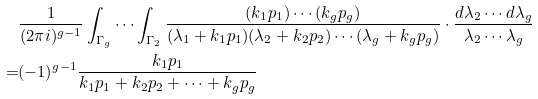<formula> <loc_0><loc_0><loc_500><loc_500>& \frac { 1 } { ( 2 \pi i ) ^ { g - 1 } } \int _ { \Gamma _ { g } } \cdots \int _ { \Gamma _ { 2 } } \frac { ( k _ { 1 } p _ { 1 } ) \cdots ( k _ { g } p _ { g } ) } { ( \lambda _ { 1 } + k _ { 1 } p _ { 1 } ) ( \lambda _ { 2 } + k _ { 2 } p _ { 2 } ) \cdots ( \lambda _ { g } + k _ { g } p _ { g } ) } \cdot \frac { d \lambda _ { 2 } \cdots d \lambda _ { g } } { \lambda _ { 2 } \cdots \lambda _ { g } } \\ = & ( - 1 ) ^ { g - 1 } \frac { k _ { 1 } p _ { 1 } } { k _ { 1 } p _ { 1 } + k _ { 2 } p _ { 2 } + \cdots + k _ { g } p _ { g } }</formula> 